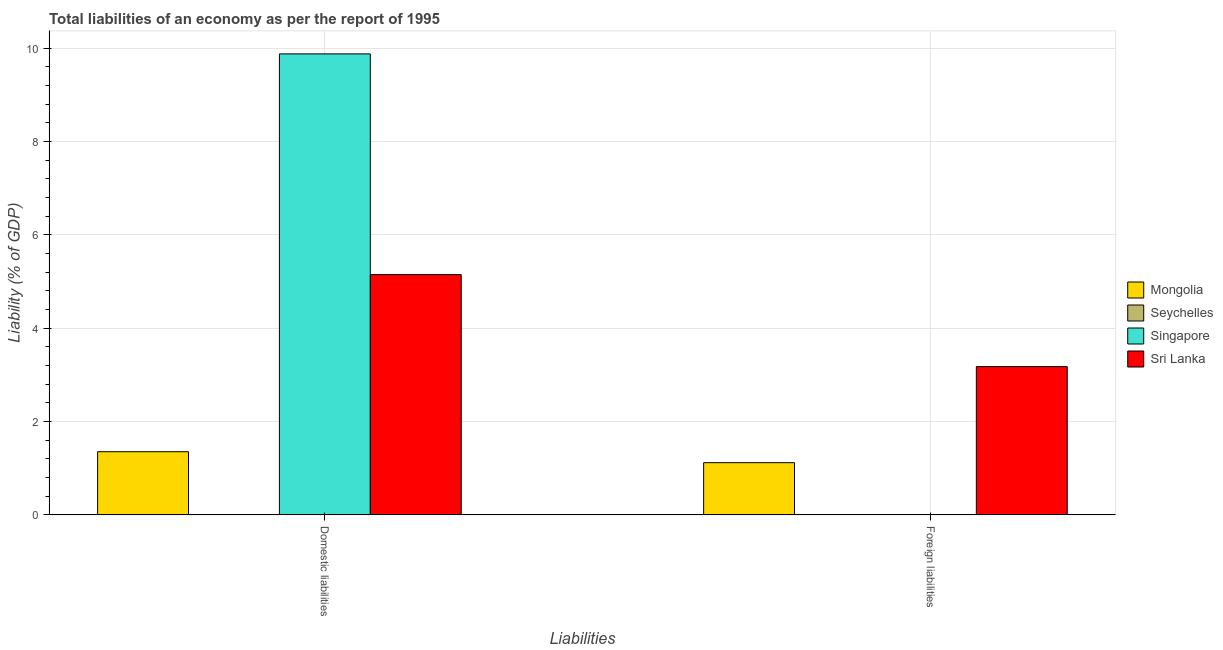How many different coloured bars are there?
Your response must be concise. 3. How many groups of bars are there?
Make the answer very short. 2. Are the number of bars on each tick of the X-axis equal?
Provide a succinct answer. No. How many bars are there on the 1st tick from the right?
Keep it short and to the point. 2. What is the label of the 2nd group of bars from the left?
Provide a short and direct response. Foreign liabilities. What is the incurrence of foreign liabilities in Seychelles?
Make the answer very short. 0. Across all countries, what is the maximum incurrence of domestic liabilities?
Keep it short and to the point. 9.88. In which country was the incurrence of foreign liabilities maximum?
Provide a succinct answer. Sri Lanka. What is the total incurrence of domestic liabilities in the graph?
Provide a succinct answer. 16.39. What is the difference between the incurrence of domestic liabilities in Mongolia and that in Sri Lanka?
Provide a succinct answer. -3.8. What is the difference between the incurrence of domestic liabilities in Mongolia and the incurrence of foreign liabilities in Seychelles?
Offer a terse response. 1.35. What is the average incurrence of domestic liabilities per country?
Your answer should be very brief. 4.1. What is the difference between the incurrence of domestic liabilities and incurrence of foreign liabilities in Mongolia?
Offer a terse response. 0.24. What is the ratio of the incurrence of domestic liabilities in Singapore to that in Mongolia?
Your answer should be very brief. 7.29. In how many countries, is the incurrence of foreign liabilities greater than the average incurrence of foreign liabilities taken over all countries?
Offer a terse response. 2. Are all the bars in the graph horizontal?
Your response must be concise. No. How many countries are there in the graph?
Give a very brief answer. 4. Are the values on the major ticks of Y-axis written in scientific E-notation?
Offer a terse response. No. Where does the legend appear in the graph?
Your response must be concise. Center right. How are the legend labels stacked?
Provide a succinct answer. Vertical. What is the title of the graph?
Make the answer very short. Total liabilities of an economy as per the report of 1995. What is the label or title of the X-axis?
Your answer should be compact. Liabilities. What is the label or title of the Y-axis?
Give a very brief answer. Liability (% of GDP). What is the Liability (% of GDP) in Mongolia in Domestic liabilities?
Your response must be concise. 1.35. What is the Liability (% of GDP) of Seychelles in Domestic liabilities?
Your response must be concise. 0. What is the Liability (% of GDP) of Singapore in Domestic liabilities?
Offer a terse response. 9.88. What is the Liability (% of GDP) of Sri Lanka in Domestic liabilities?
Keep it short and to the point. 5.15. What is the Liability (% of GDP) in Mongolia in Foreign liabilities?
Ensure brevity in your answer.  1.12. What is the Liability (% of GDP) in Seychelles in Foreign liabilities?
Make the answer very short. 0. What is the Liability (% of GDP) in Sri Lanka in Foreign liabilities?
Make the answer very short. 3.18. Across all Liabilities, what is the maximum Liability (% of GDP) in Mongolia?
Ensure brevity in your answer.  1.35. Across all Liabilities, what is the maximum Liability (% of GDP) of Singapore?
Provide a short and direct response. 9.88. Across all Liabilities, what is the maximum Liability (% of GDP) of Sri Lanka?
Make the answer very short. 5.15. Across all Liabilities, what is the minimum Liability (% of GDP) in Mongolia?
Offer a very short reply. 1.12. Across all Liabilities, what is the minimum Liability (% of GDP) of Singapore?
Keep it short and to the point. 0. Across all Liabilities, what is the minimum Liability (% of GDP) in Sri Lanka?
Make the answer very short. 3.18. What is the total Liability (% of GDP) of Mongolia in the graph?
Offer a terse response. 2.47. What is the total Liability (% of GDP) in Singapore in the graph?
Provide a short and direct response. 9.88. What is the total Liability (% of GDP) in Sri Lanka in the graph?
Your answer should be very brief. 8.33. What is the difference between the Liability (% of GDP) of Mongolia in Domestic liabilities and that in Foreign liabilities?
Keep it short and to the point. 0.24. What is the difference between the Liability (% of GDP) of Sri Lanka in Domestic liabilities and that in Foreign liabilities?
Your answer should be compact. 1.97. What is the difference between the Liability (% of GDP) in Mongolia in Domestic liabilities and the Liability (% of GDP) in Sri Lanka in Foreign liabilities?
Your response must be concise. -1.82. What is the difference between the Liability (% of GDP) in Singapore in Domestic liabilities and the Liability (% of GDP) in Sri Lanka in Foreign liabilities?
Make the answer very short. 6.7. What is the average Liability (% of GDP) of Mongolia per Liabilities?
Ensure brevity in your answer.  1.24. What is the average Liability (% of GDP) in Seychelles per Liabilities?
Your response must be concise. 0. What is the average Liability (% of GDP) in Singapore per Liabilities?
Your answer should be compact. 4.94. What is the average Liability (% of GDP) of Sri Lanka per Liabilities?
Make the answer very short. 4.16. What is the difference between the Liability (% of GDP) of Mongolia and Liability (% of GDP) of Singapore in Domestic liabilities?
Offer a very short reply. -8.53. What is the difference between the Liability (% of GDP) in Mongolia and Liability (% of GDP) in Sri Lanka in Domestic liabilities?
Ensure brevity in your answer.  -3.8. What is the difference between the Liability (% of GDP) in Singapore and Liability (% of GDP) in Sri Lanka in Domestic liabilities?
Your answer should be very brief. 4.73. What is the difference between the Liability (% of GDP) of Mongolia and Liability (% of GDP) of Sri Lanka in Foreign liabilities?
Ensure brevity in your answer.  -2.06. What is the ratio of the Liability (% of GDP) in Mongolia in Domestic liabilities to that in Foreign liabilities?
Give a very brief answer. 1.21. What is the ratio of the Liability (% of GDP) of Sri Lanka in Domestic liabilities to that in Foreign liabilities?
Give a very brief answer. 1.62. What is the difference between the highest and the second highest Liability (% of GDP) in Mongolia?
Offer a terse response. 0.24. What is the difference between the highest and the second highest Liability (% of GDP) of Sri Lanka?
Provide a short and direct response. 1.97. What is the difference between the highest and the lowest Liability (% of GDP) in Mongolia?
Your response must be concise. 0.24. What is the difference between the highest and the lowest Liability (% of GDP) of Singapore?
Provide a succinct answer. 9.88. What is the difference between the highest and the lowest Liability (% of GDP) of Sri Lanka?
Provide a succinct answer. 1.97. 